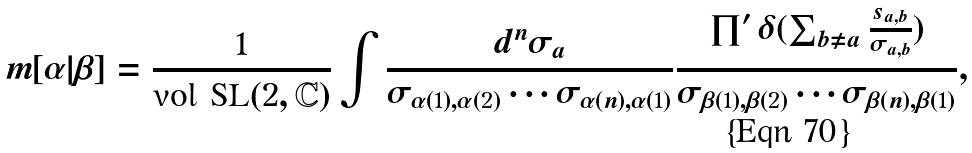Convert formula to latex. <formula><loc_0><loc_0><loc_500><loc_500>m [ \alpha | \beta ] = \frac { 1 } { \text {vol SL} ( 2 , \mathbb { C } ) } \int \frac { d ^ { n } \sigma _ { a } } { \sigma _ { \alpha ( 1 ) , \alpha ( 2 ) } \cdots \sigma _ { \alpha ( n ) , \alpha ( 1 ) } } \frac { \prod ^ { \prime } \delta ( \sum _ { b \neq a } \frac { s _ { a , b } } { \sigma _ { a , b } } ) } { \sigma _ { \beta ( 1 ) , \beta ( 2 ) } \cdots \sigma _ { \beta ( n ) , \beta ( 1 ) } } ,</formula> 